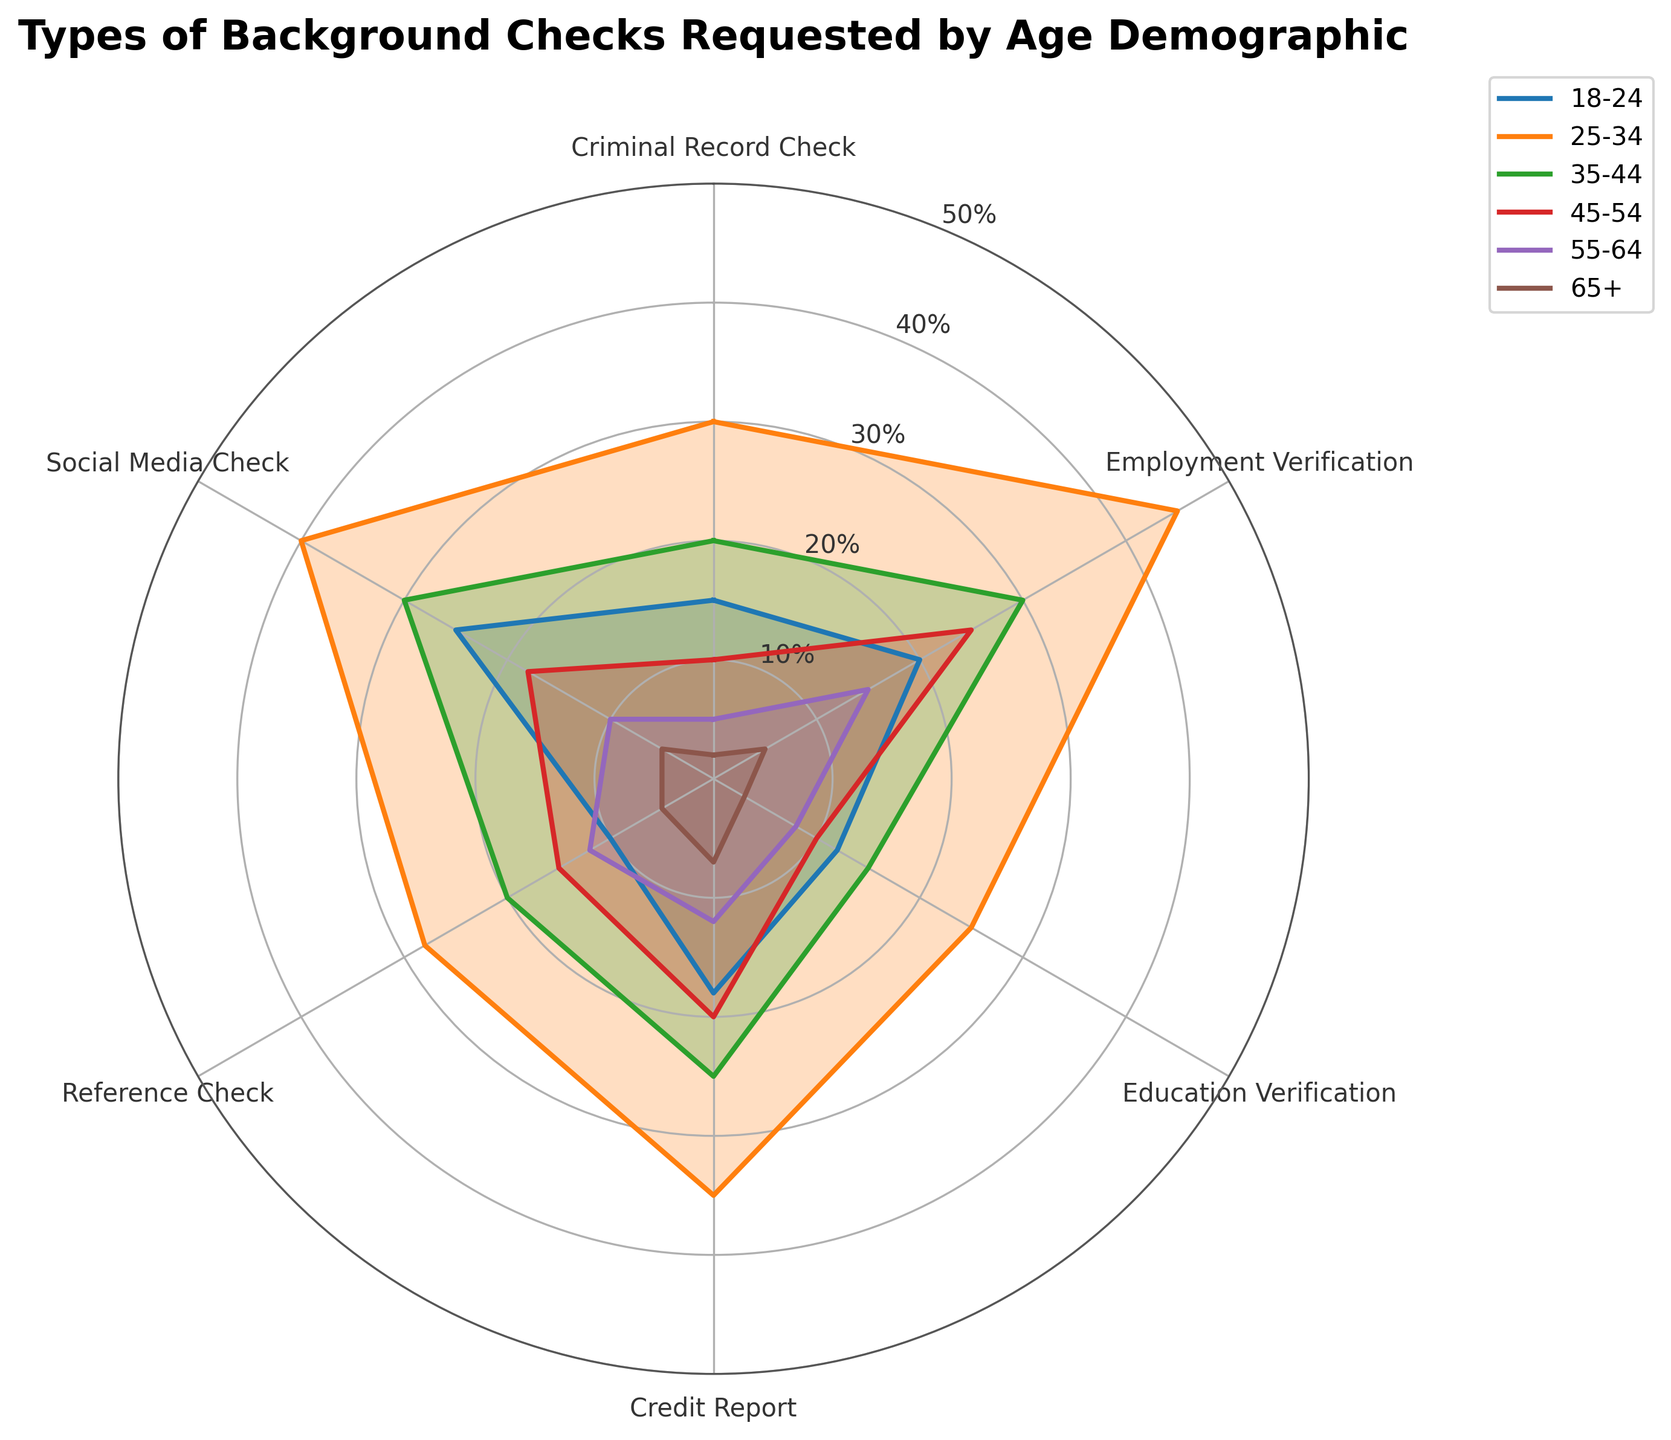What types of background checks are most requested by the 25-34 age demographic? The 25-34 age demographic is shown in the middle of the rose chart with each section representing a type of background check. The longest sections, representing the highest values, correspond to Employment Verification and Social Media Check.
Answer: Employment Verification and Social Media Check Which type of background check is least requested by the 65+ age demographic? The 65+ age demographic is shown with the smallest overall sections in the rose chart. The smallest single section for this demographic is for Criminal Record Check.
Answer: Criminal Record Check How do the values for Credit Report requests compare between the 18-24 and 45-54 age demographics? By comparing the length of the Credit Report sections for the 18-24 and 45-54 age demographics, Credit Report request has a larger section for 18-24 than for 45-54.
Answer: 18-24 has more What is the difference in the number of Education Verification requests between the 25-34 and 55-64 age demographics? The rose chart shows the lengths of each age demographic's sections. The sections for Education Verification are longer for 25-34 than for 55-64. The exact values are 25 for 25-34 and 8 for 55-64, resulting in a difference of 17.
Answer: 17 Which age demographic requests the highest number of Reference Checks? The Reference Check sections of the rose chart for each age demographic can be compared. The longest section belongs to the 25-34 age demographic.
Answer: 25-34 What is the average number of Social Media Checks requested by age demographics 18-24, 25-34, and 35-44? To find the average, sum the values of Social Media Checks for the 18-24 (25), 25-34 (40), and 35-44 (30) age demographics and divide by 3. This results in (25 + 40 + 30) / 3 = 95 / 3 ≈ 31.67.
Answer: 31.67 How many more Employment Verifications are requested by the 25-34 age demographic compared to the 35-44 age demographic? The lengths of the Employment Verification sections can be compared. The 25-34 demographic has 45 requests while the 35-44 demographic has 30 requests, resulting in a difference of 15.
Answer: 15 Which age demographic has the smallest overall number of background checks requested across all types? The rose chart areas for each age demographic indicate the total number of checks requested. The smallest total area corresponds to the 65+ demographic.
Answer: 65+ Which type of background check shows the most consistent number of requests across all age demographics? Observing the rose chart, the Reference Check sections show relatively smaller variations in length across different age demographics compared to others like Employment Verification and Social Media Check.
Answer: Reference Check 